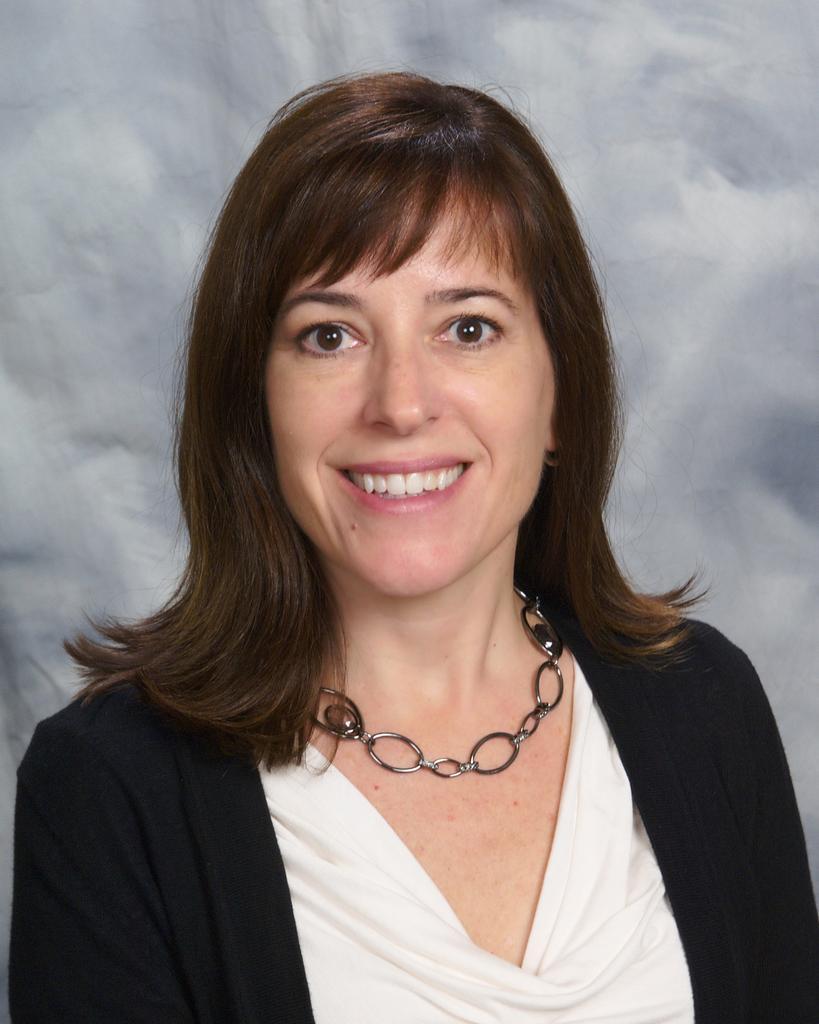Describe this image in one or two sentences. In the center of the image there is a lady. She is smiling. In the background there is a wall. 